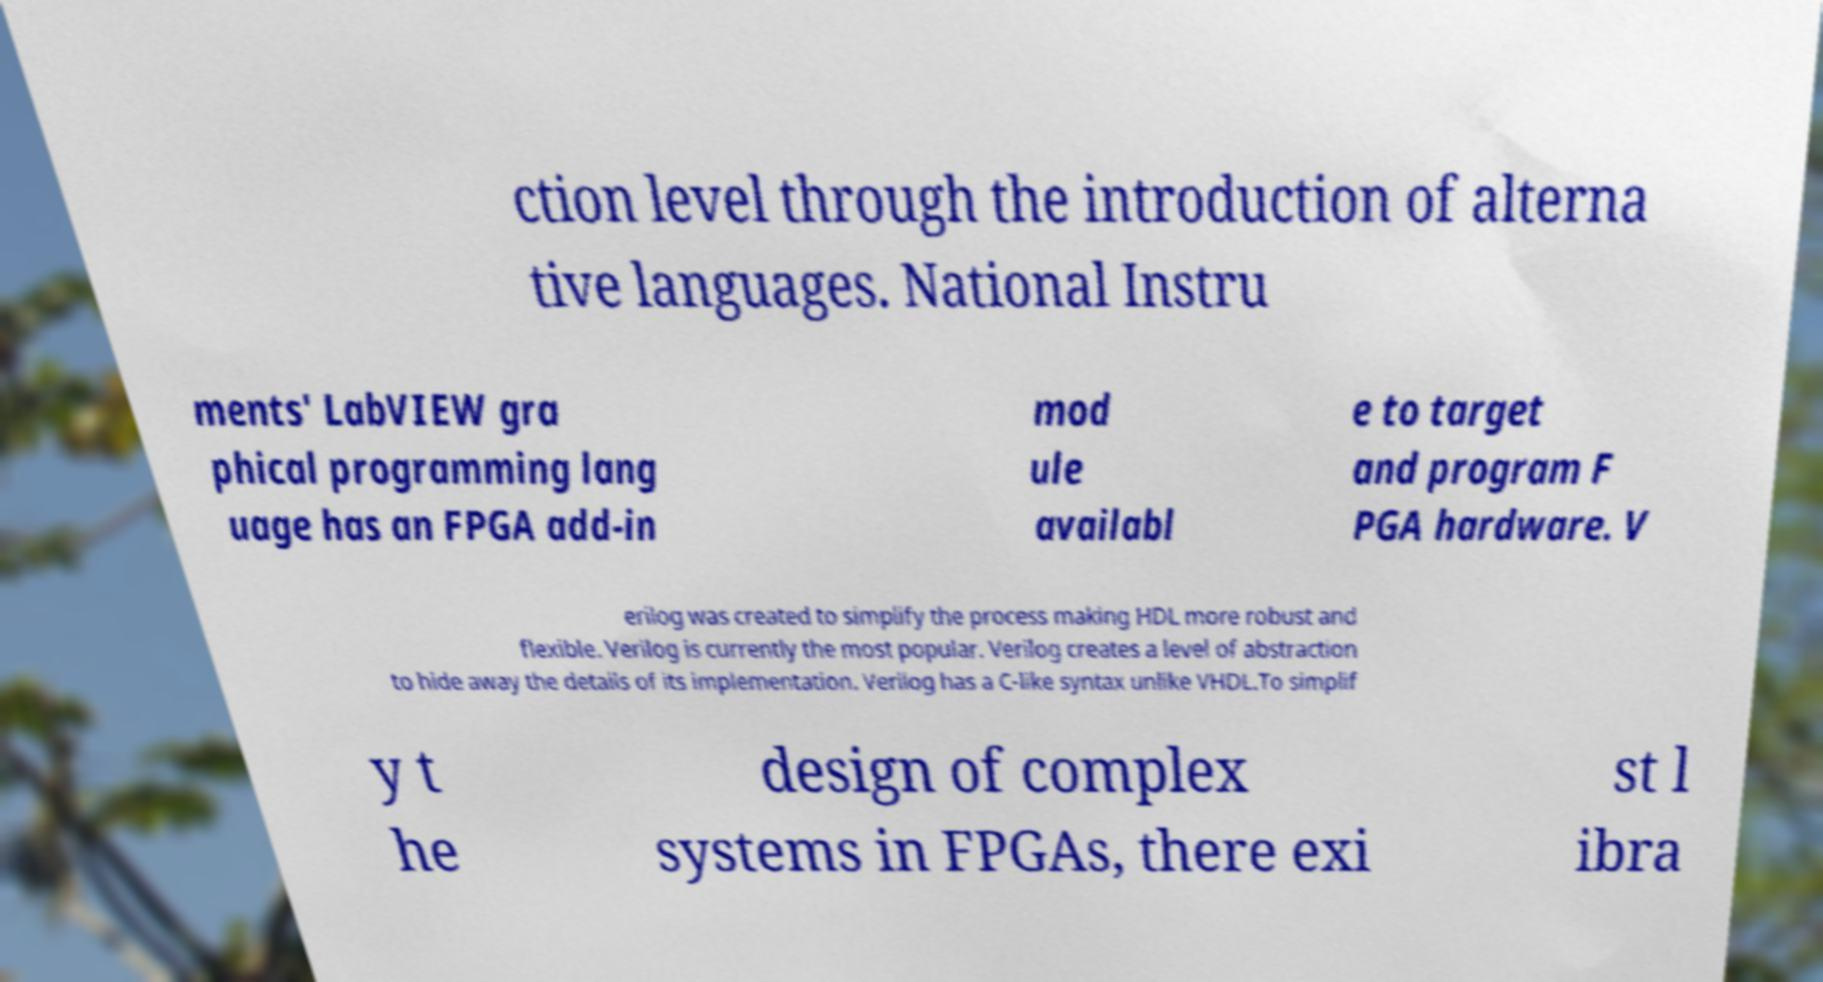Can you accurately transcribe the text from the provided image for me? ction level through the introduction of alterna tive languages. National Instru ments' LabVIEW gra phical programming lang uage has an FPGA add-in mod ule availabl e to target and program F PGA hardware. V erilog was created to simplify the process making HDL more robust and flexible. Verilog is currently the most popular. Verilog creates a level of abstraction to hide away the details of its implementation. Verilog has a C-like syntax unlike VHDL.To simplif y t he design of complex systems in FPGAs, there exi st l ibra 